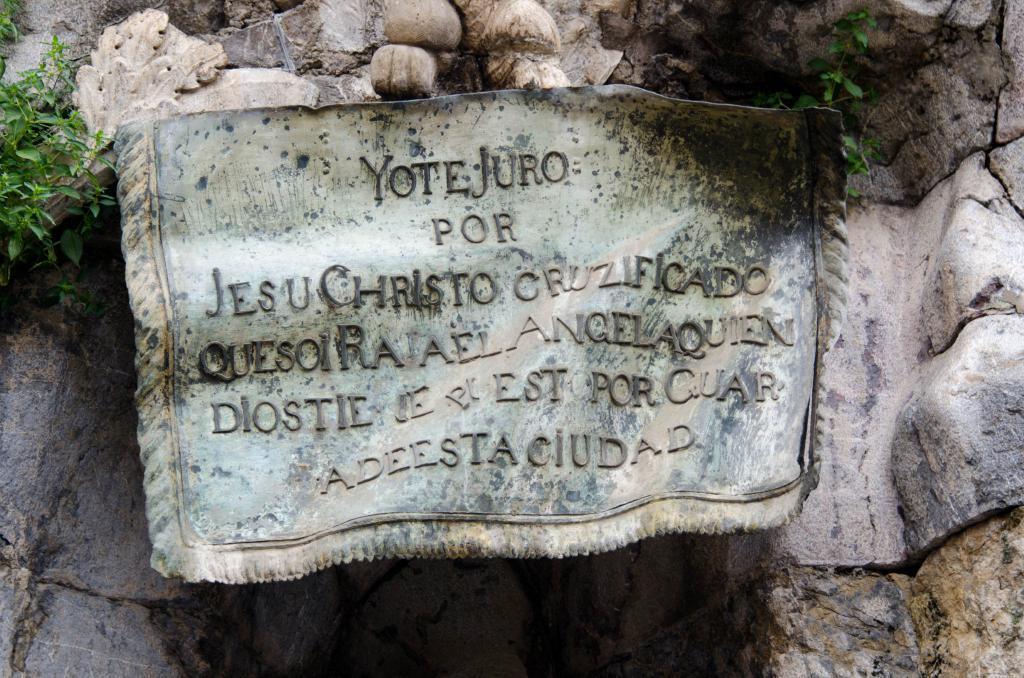Describe this image in one or two sentences. In this image, we can see few plants and rocks. Here we can see some text. 